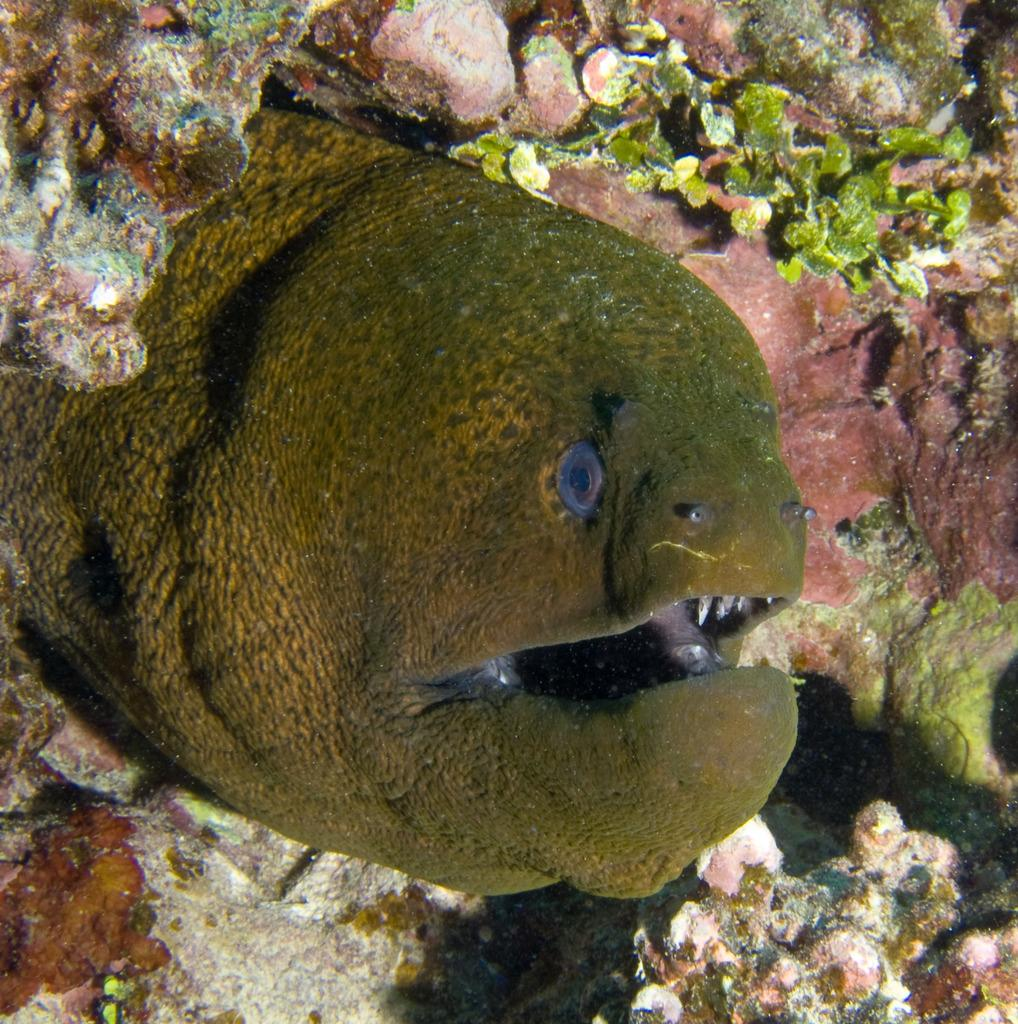What type of animal is in the image? There is a fish in the image. What other objects or features can be seen in the image? There are corals in the image. Where are the fish and corals located? The fish and corals are in water. What type of skin condition can be seen on the fish in the image? There is no indication of a skin condition on the fish in the image. Can you see a hand holding the fish in the image? There is no hand visible in the image. --- Facts: 1. There is a car in the image. 2. The car is red. 3. The car has four wheels. 4. There is a road in the image. 5. The road is paved. Absurd Topics: bird, mountain, ocean Conversation: What is the main subject of the image? The main subject of the image is a car. Can you describe the car in the image? The car is red and has four wheels. What is the setting of the image? The car is on a road. Can you describe the road in the image? The road is paved. Reasoning: Let's think step by step in order to produce the conversation. We start by identifying the main subject of the image, which is the car. Next, we describe the car's color and number of wheels. Then, we provide context for the car's location by mentioning that it is on a road. Finally, we describe the road's surface, which is paved. Absurd Question/Answer: Can you see a bird flying over the mountain in the image? There is no mountain or bird visible in the image. Is the car driving near the ocean in the image? There is no ocean visible in the image. 